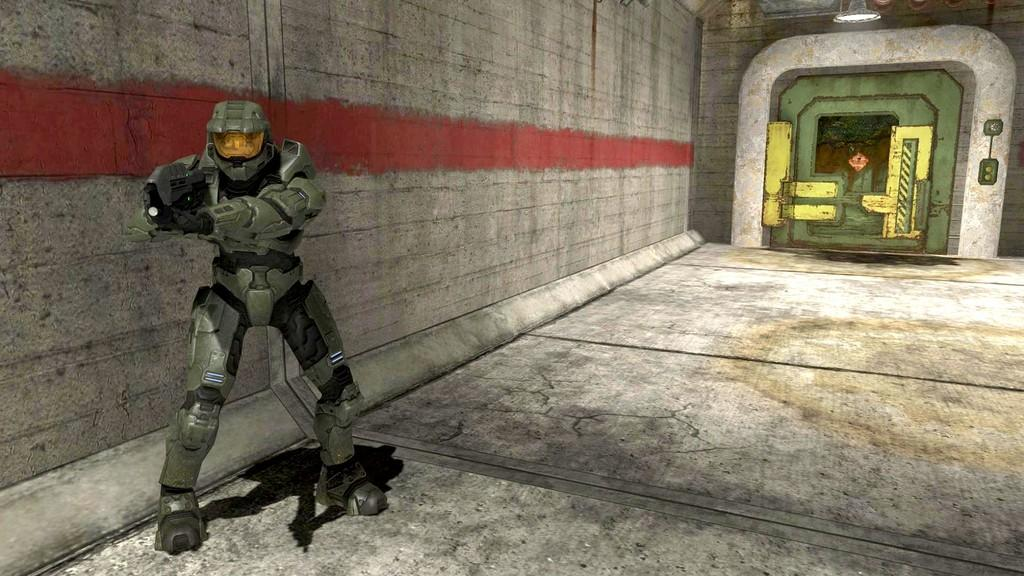What is the person in the image wearing? The person is wearing a soldier costume, helmet, gloves, and shoes. What is the person holding in their hands? The person is holding a gun in their hands. What type of floor is visible in the image? There is a floor in the image, but the specific type of floor cannot be determined from the facts provided. What other structures are present in the image? There is a wall, a light, and a door in the image. Can you see any ladybugs crawling on the wall in the image? There are no ladybugs present in the image. Is the person in the image standing on a level surface or on a slope? The facts provided do not give any information about the levelness of the surface the person is standing on. 